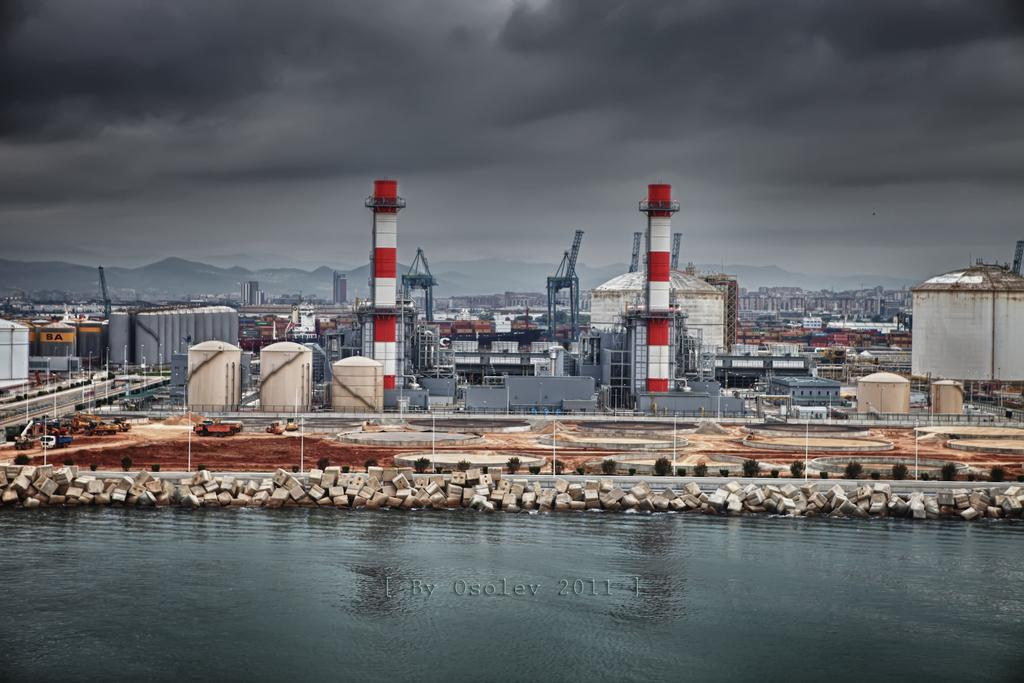What is the main structure in the center of the image? There is a power station in the center of the image. What can be seen at the bottom of the image? There is water at the bottom of the image, with rocks visible in it. What types of vehicles are present in the image? There are vehicles in the image, but their specific types are not mentioned. What can be seen in the background of the image? There are hills and the sky visible in the background of the image. What type of lace is draped over the power station in the image? There is no lace present in the image; it features a power station, water, rocks, vehicles, hills, and the sky. Can you see any gloves being used by the people in the image? There are no people or gloves visible in the image. 